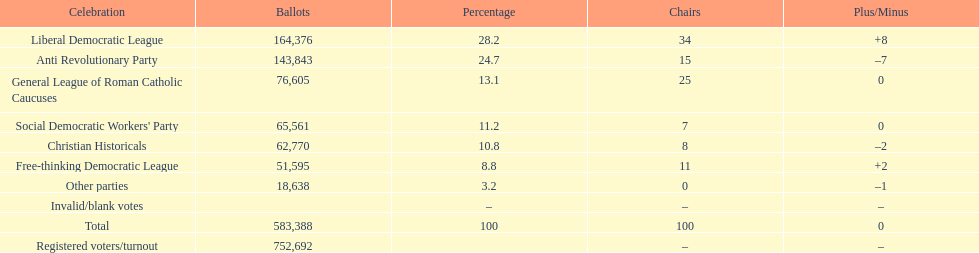How many more votes did the liberal democratic league win over the free-thinking democratic league? 112,781. 